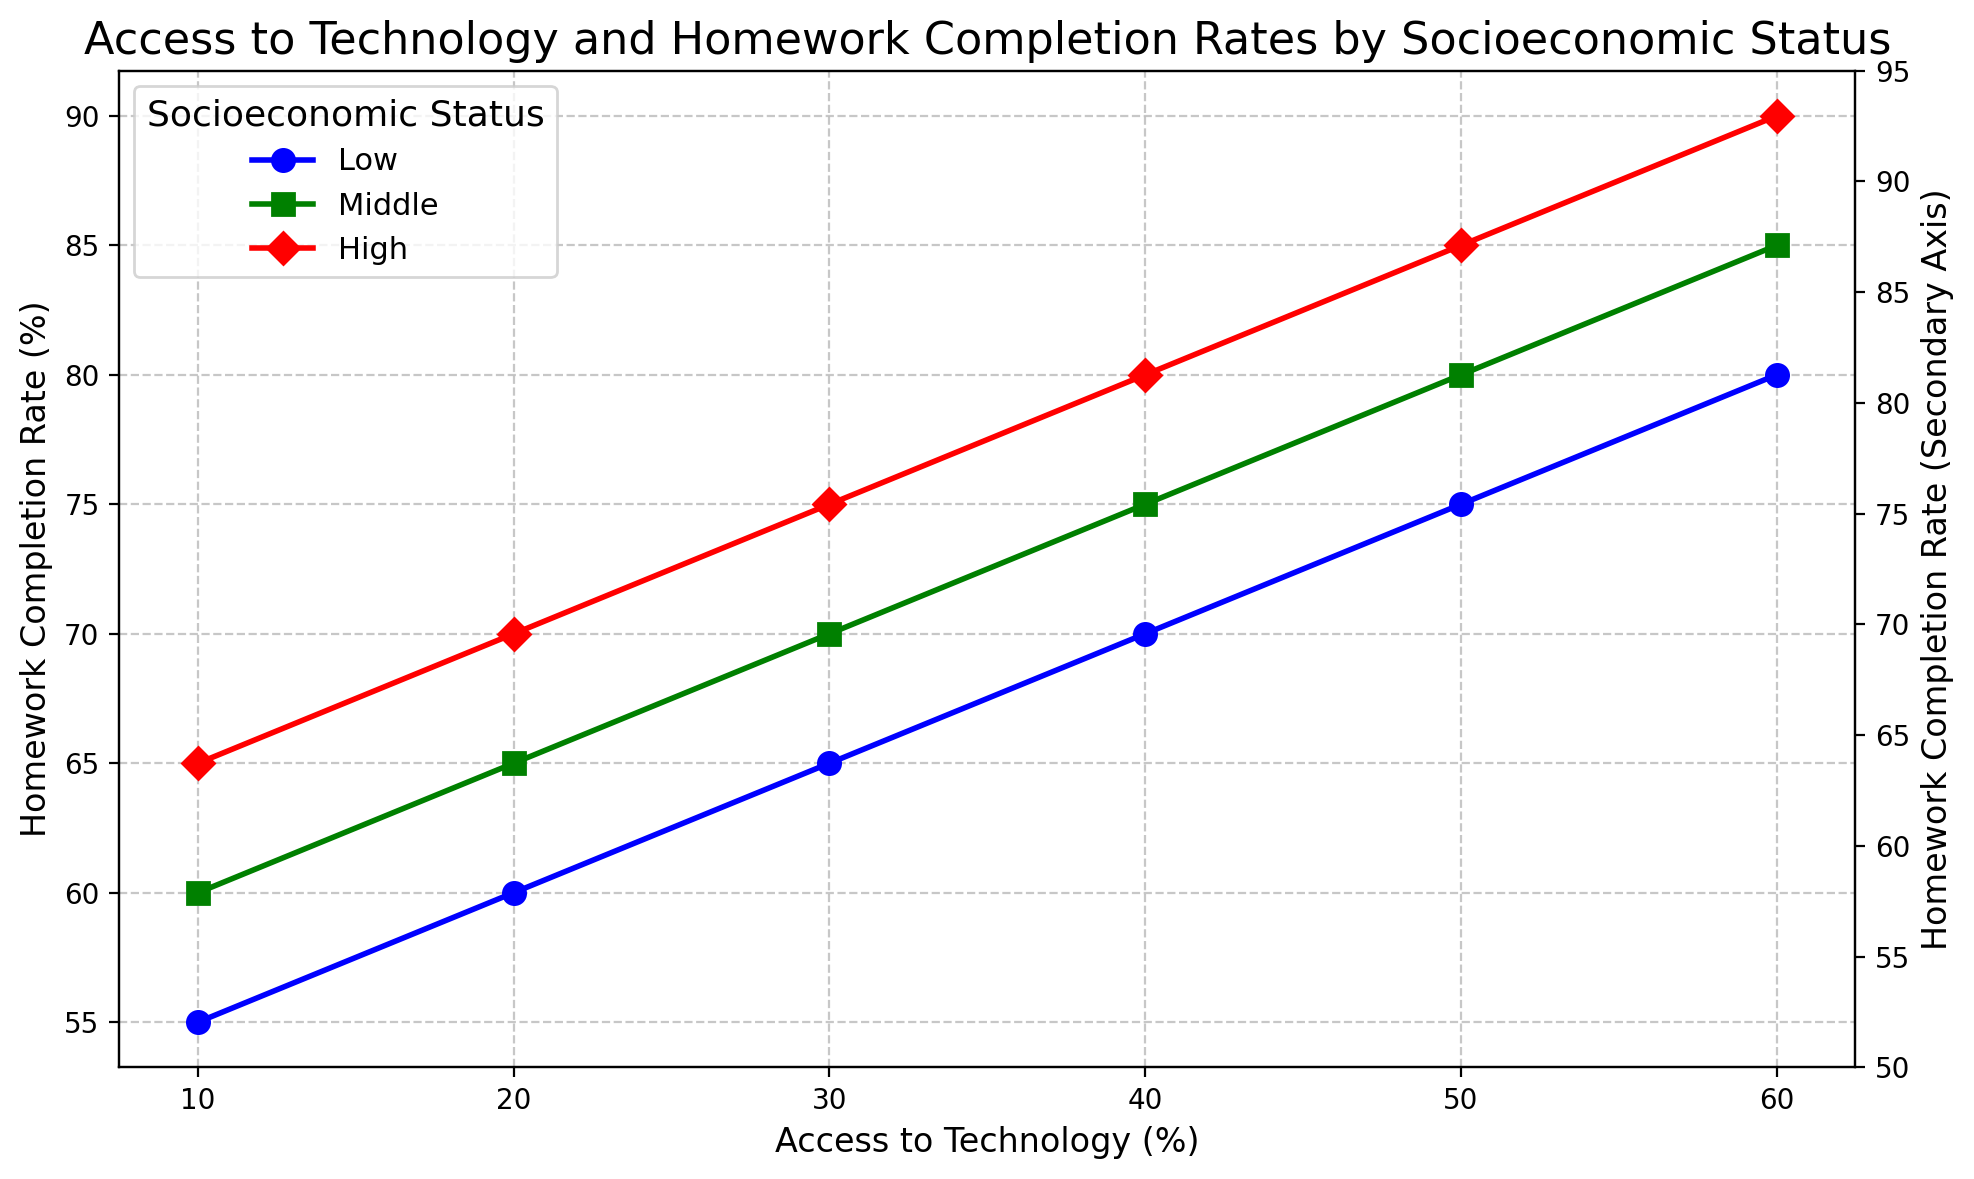What is the general trend in homework completion rates as access to technology increases for each socioeconomic status? As access to technology increases, homework completion rates also increase for each socioeconomic status group. This trend is noticeable across all three groups (Low, Middle, and High) when observing the upwards sloping lines in the plot.
Answer: Increases Which socioeconomic status group has the highest homework completion rate when access to technology is at 60%? Looking at the right-most side of the plot (where access to technology is 60%), the red "High" group has the highest homework completion rate, followed by the green "Middle" group, and then the blue "Low" group.
Answer: High What is the difference in homework completion rates between 'Low' and 'High' socioeconomic status when access to technology is at 30%? At 30% access to technology, 'Low' status has a completion rate of 65%, and 'High' status has a completion rate of 75%. The difference is calculated as 75% - 65% = 10%.
Answer: 10% How do the homework completion rates compare between 'Middle' and 'High' socioeconomic status groups at different levels of access to technology? At each increment of access to technology (10%, 20%, etc.), the homework completion rate of the 'Middle' group is consistently 5% lower than the 'High' group. For example, at 10% access, 'Middle' is at 60% while 'High' is at 65%. At 20%, 'Middle' is at 65% whereas 'High' is at 70%, and this pattern continues.
Answer: 'High' is consistently 5% higher What can be inferred from the grid lines and markers about the overall variability in homework completion rates among different socioeconomic status groups? The usage of grid lines and markers helps illustrate that the rate of increase in homework completion is similar among the different socioeconomic groups; however, the absolute levels differ. 'High' status consistently has the highest rates while 'Low' status has the lowest rates at corresponding points of technology access.
Answer: 'High' status consistently has the highest, 'Low' the lowest At 50% access to technology, what is the average homework completion rate across all socioeconomic groups? The homework completion rates at 50% access are: Low (75%), Middle (80%), and High (85%). The average can be calculated as (75 + 80 + 85)/3 = 240/3 = 80%.
Answer: 80% Which socioeconomic status group shows the fastest increase in homework completion rates as access to technology rises from 10% to 60%? By measuring the slope of the line for each group, it's evident that 'High' status has the steepest upward trajectory. The increase is from 65% to 90%, which is a 25% increase. 'Middle' rises from 60% to 85% (25% increase), and 'Low' rises from 55% to 80% (also a 25% increase). However, all groups show the same rate of increase when considering the interval from 10% to 60% access.
Answer: All groups equally 